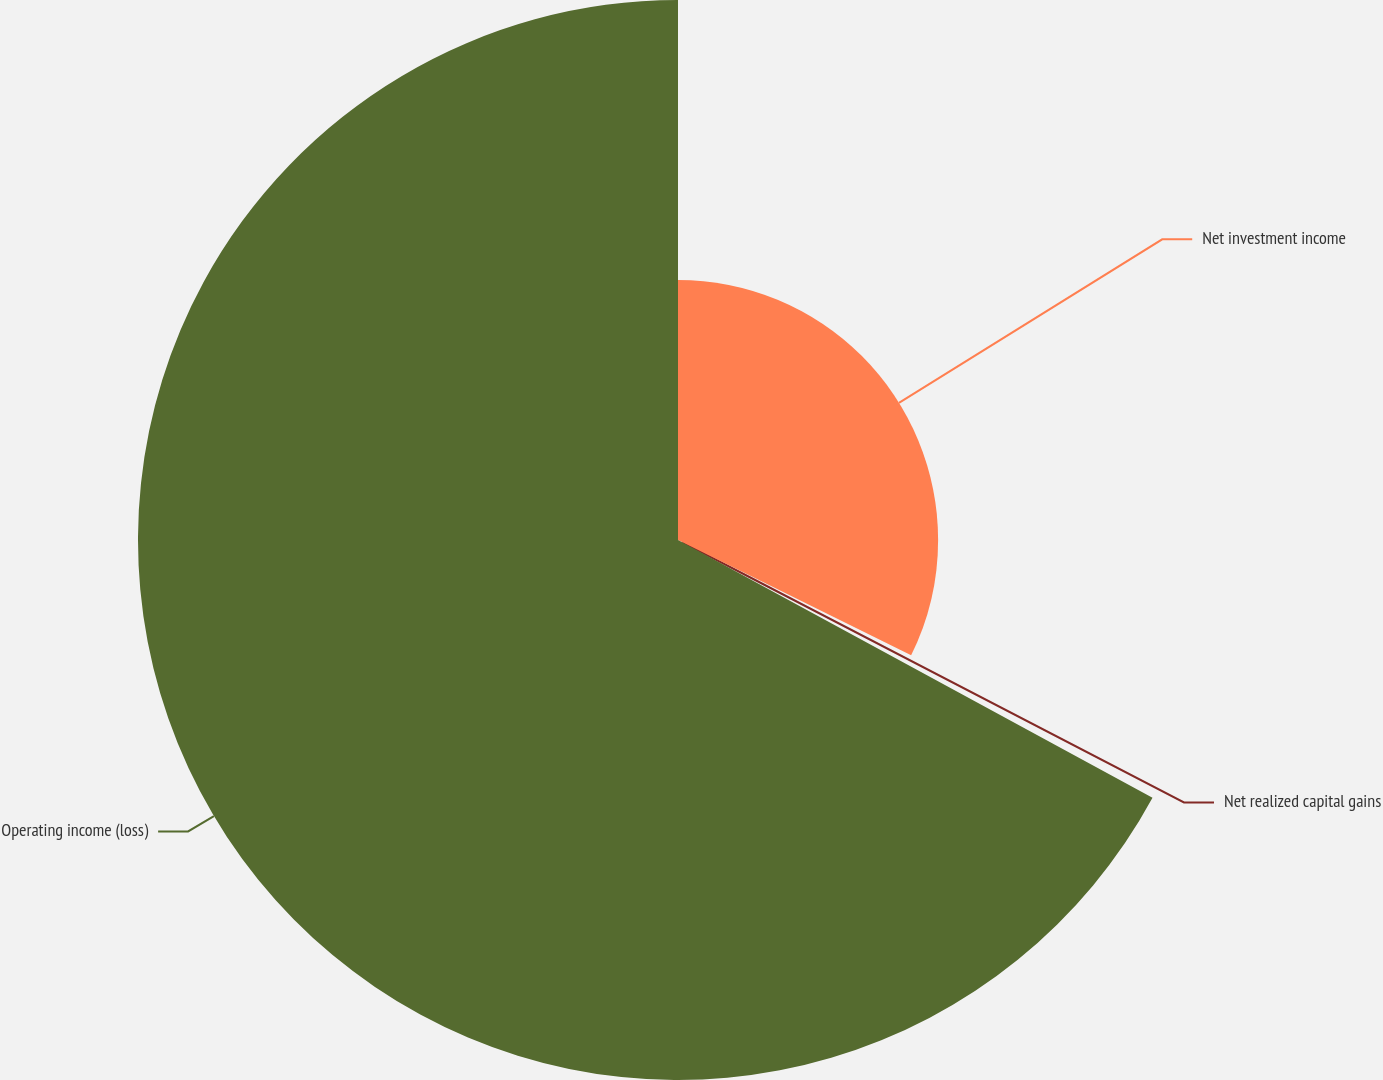Convert chart to OTSL. <chart><loc_0><loc_0><loc_500><loc_500><pie_chart><fcel>Net investment income<fcel>Net realized capital gains<fcel>Operating income (loss)<nl><fcel>32.31%<fcel>0.61%<fcel>67.08%<nl></chart> 